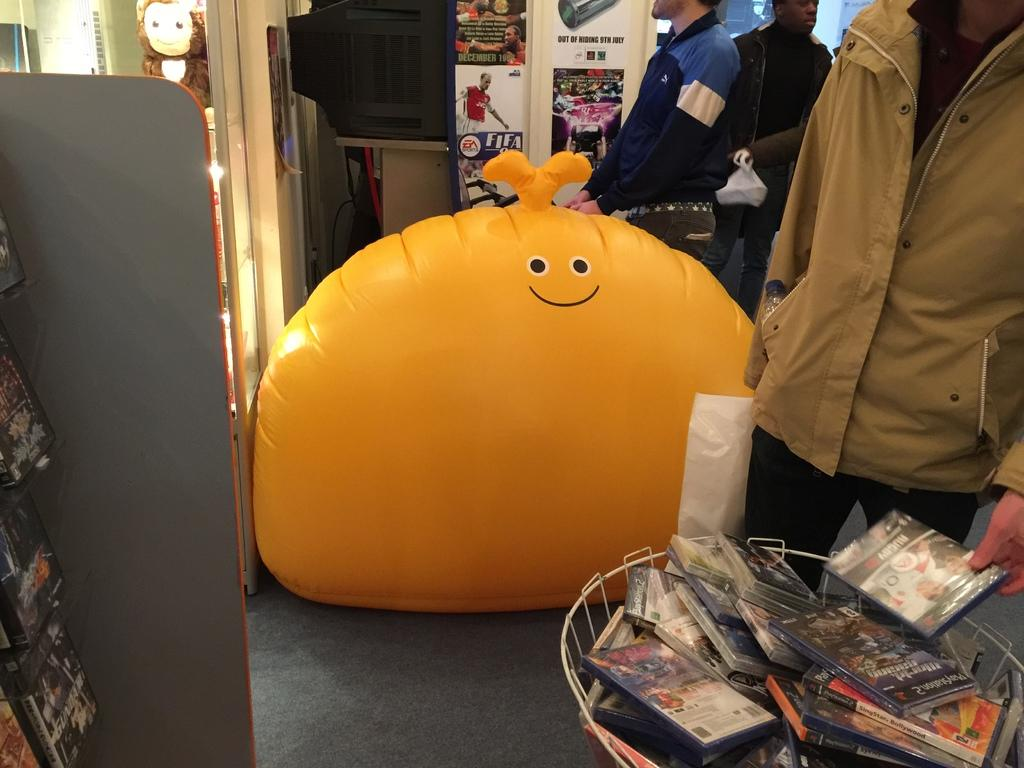<image>
Present a compact description of the photo's key features. A small table has games on it for the Playstation 2. 